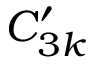<formula> <loc_0><loc_0><loc_500><loc_500>C _ { 3 k } ^ { \prime }</formula> 